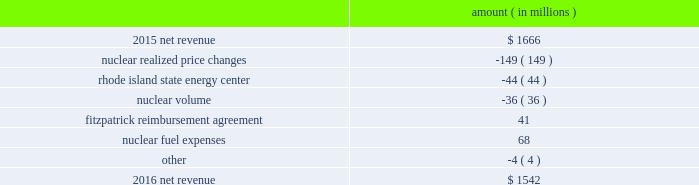Entergy corporation and subsidiaries management 2019s financial discussion and analysis combination .
Consistent with the terms of the stipulated settlement in the business combination proceeding , electric customers of entergy louisiana will realize customer credits associated with the business combination ; accordingly , in october 2015 , entergy recorded a regulatory liability of $ 107 million ( $ 66 million net-of-tax ) .
These costs are being amortized over a nine-year period beginning december 2015 .
See note 2 to the financial statements for further discussion of the business combination and customer credits .
The volume/weather variance is primarily due to the effect of more favorable weather during the unbilled period and an increase in industrial usage , partially offset by the effect of less favorable weather on residential sales .
The increase in industrial usage is primarily due to expansion projects , primarily in the chemicals industry , and increased demand from new customers , primarily in the industrial gases industry .
The louisiana act 55 financing savings obligation variance results from a regulatory charge for tax savings to be shared with customers per an agreement approved by the lpsc .
The tax savings results from the 2010-2011 irs audit settlement on the treatment of the louisiana act 55 financing of storm costs for hurricane gustav and hurricane ike .
See note 3 to the financial statements for additional discussion of the settlement and benefit sharing .
Included in other is a provision of $ 23 million recorded in 2016 related to the settlement of the waterford 3 replacement steam generator prudence review proceeding , offset by a provision of $ 32 million recorded in 2015 related to the uncertainty at that time associated with the resolution of the waterford 3 replacement steam generator prudence review proceeding .
See note 2 to the financial statements for a discussion of the waterford 3 replacement steam generator prudence review proceeding .
Entergy wholesale commodities following is an analysis of the change in net revenue comparing 2016 to 2015 .
Amount ( in millions ) .
As shown in the table above , net revenue for entergy wholesale commodities decreased by approximately $ 124 million in 2016 primarily due to : 2022 lower realized wholesale energy prices and lower capacity prices , although the average revenue per mwh shown in the table below for the nuclear fleet is slightly higher because it includes revenues from the fitzpatrick reimbursement agreement with exelon , the amortization of the palisades below-market ppa , and vermont yankee capacity revenue .
The effect of the amortization of the palisades below-market ppa and vermont yankee capacity revenue on the net revenue variance from 2015 to 2016 is minimal ; 2022 the sale of the rhode island state energy center in december 2015 .
See note 14 to the financial statements for further discussion of the rhode island state energy center sale ; and 2022 lower volume in the entergy wholesale commodities nuclear fleet resulting from more refueling outage days in 2016 as compared to 2015 and larger exercise of resupply options in 2016 as compared to 2015 .
See 201cnuclear .
What is the growth rate in net revenue in 2016? 
Computations: ((1542 - 1666) / 1666)
Answer: -0.07443. 